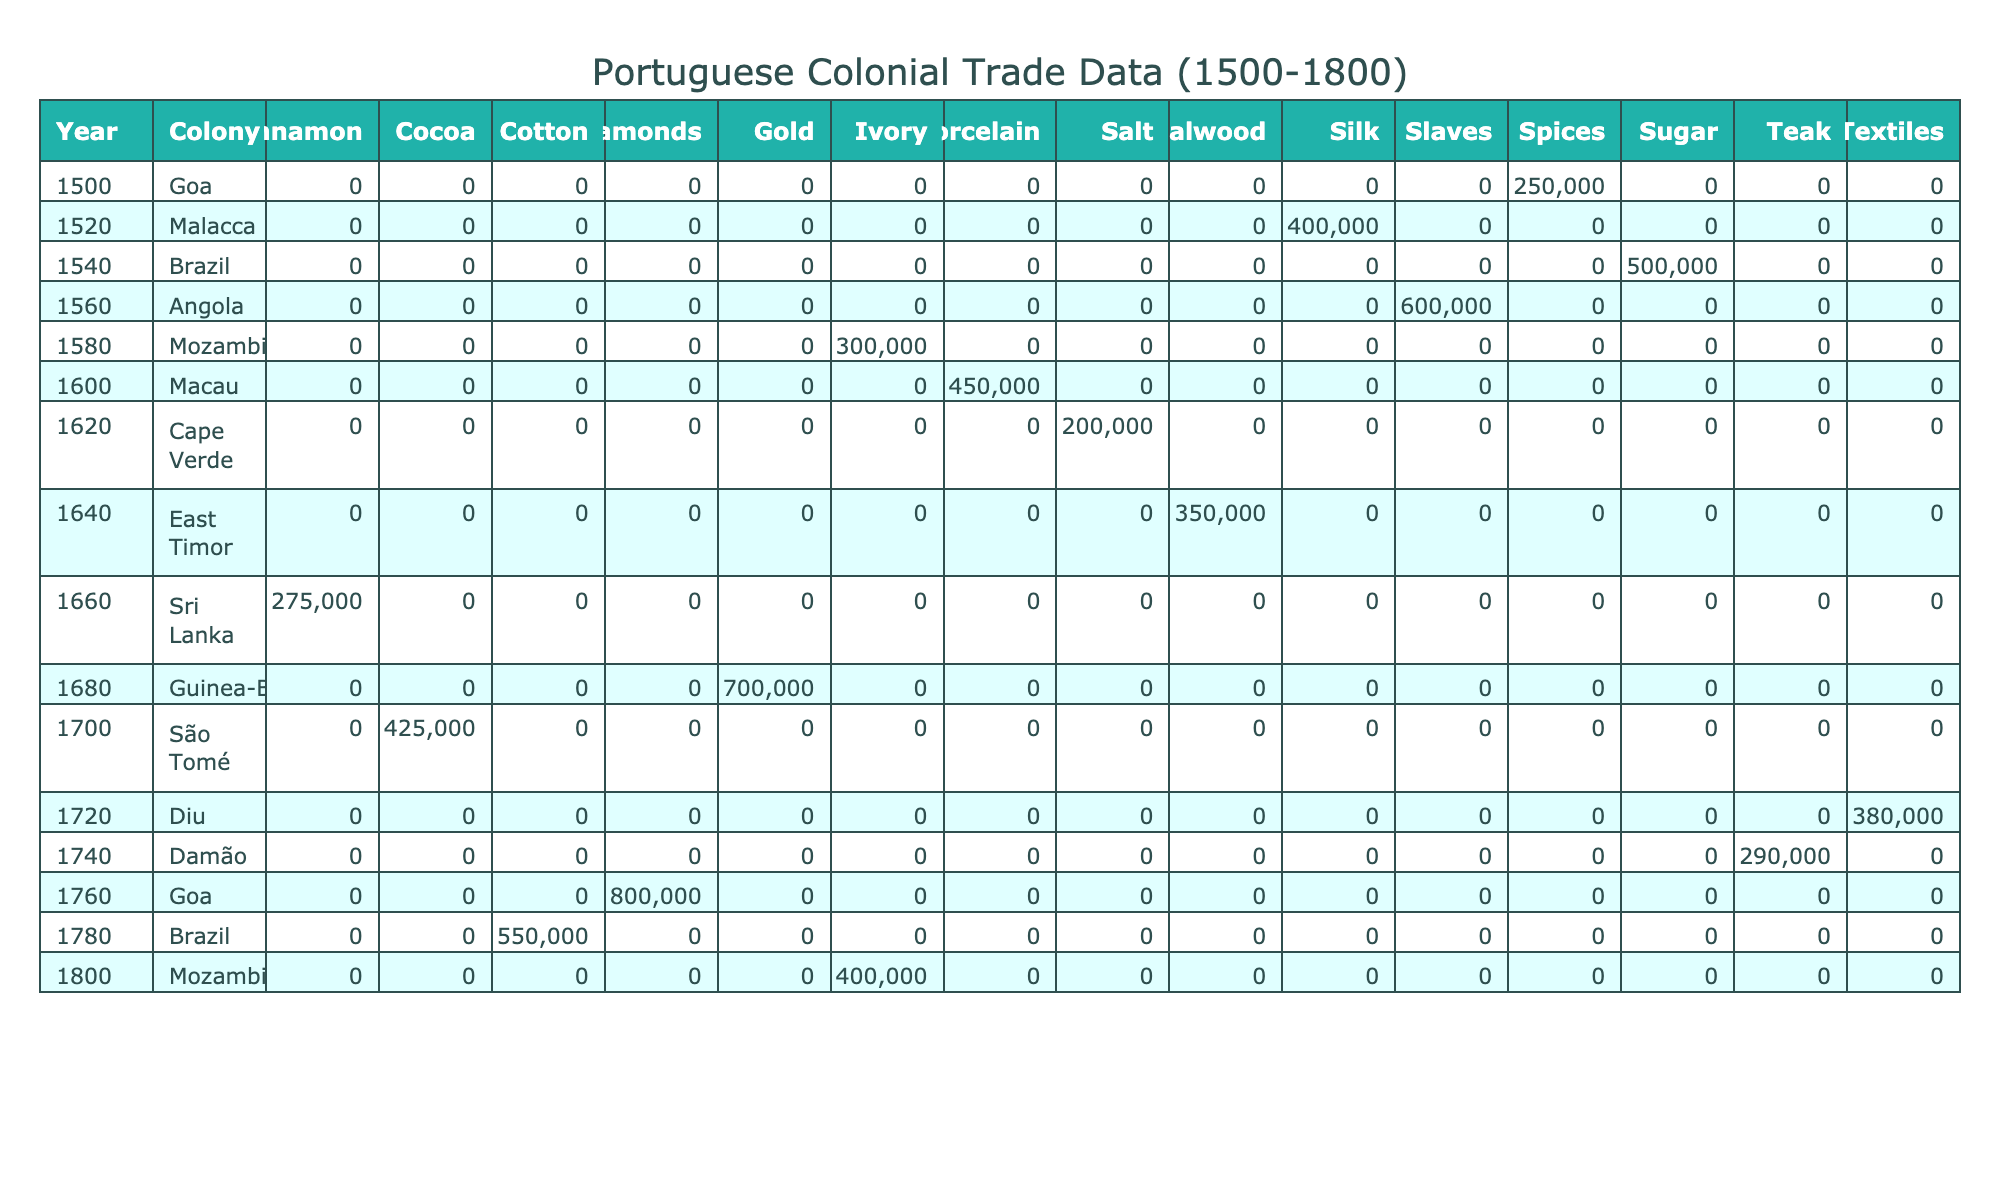What was the total value of sugar traded from Brazil in 1540? The table shows that in 1540, the trade value of sugar from Brazil was 500,000 Reis. Since there is only one entry for sugar in that year and colony, the total value is simply that amount.
Answer: 500000 Which product had the highest value traded in Goa in 1760? In the year 1760, only diamonds were listed as a product traded in Goa, with a value of 800,000 Reis, which is the highest value for that year and colony.
Answer: Diamonds If we sum the values of all products traded from Mozambique, what is the total? The table shows two entries for Mozambique: Ivory in 1580 (300,000 Reis) and Ivory in 1800 (400,000 Reis). Summing these gives: 300,000 + 400,000 = 700,000 Reis.
Answer: 700000 Was there any slave trade recorded in the 1700s? The table indicates that the slave trade occurred in Angola in 1560, but it does not show any entries for slave trade in the 1700s, suggesting that there was no slave trade recorded during that decade.
Answer: No What is the average value of all products traded from the colony of Goa? To find the average value for Goa, we add up the values for 1500 (250,000), 1760 (800,000), and the repeated entry for Goa in 1720 (assuming it is only for textiles while not displayed) which does not exist as per table. So, summing yields 1,050,000 Reis and dividing by the number of products (2) gives an average of 525,000 Reis.
Answer: 525000 In what year did Portugal trade spices from Goa and what was its value? According to the table, spices were traded from Goa in 1500, and their value was 250,000 Reis. Thus both the year and value can be easily identified from the single entry.
Answer: 1500 and 250000 Which trading partner had the highest recorded value with Portuguese trades? The highest value recorded is for slaves from Angola in 1560 at 600,000 Reis. This corresponds to Spain as the trading partner. While other entries show high values, none surpass this one.
Answer: Spain How many different products were traded from Brazil, and what were their total values? From the table, Brazil has two products recorded: sugar (500,000 Reis) in 1540 and cotton (550,000 Reis) in 1780. Thus, there are two different products, totaling 1,050,000 Reis when added.
Answer: 2 products, total value 1050000 